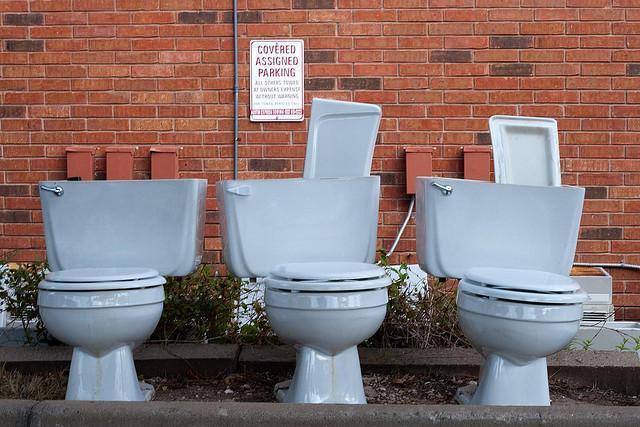How many toilet bowls are sat in this area next to the side of the street?
Choose the right answer from the provided options to respond to the question.
Options: One, four, two, three. Three. 